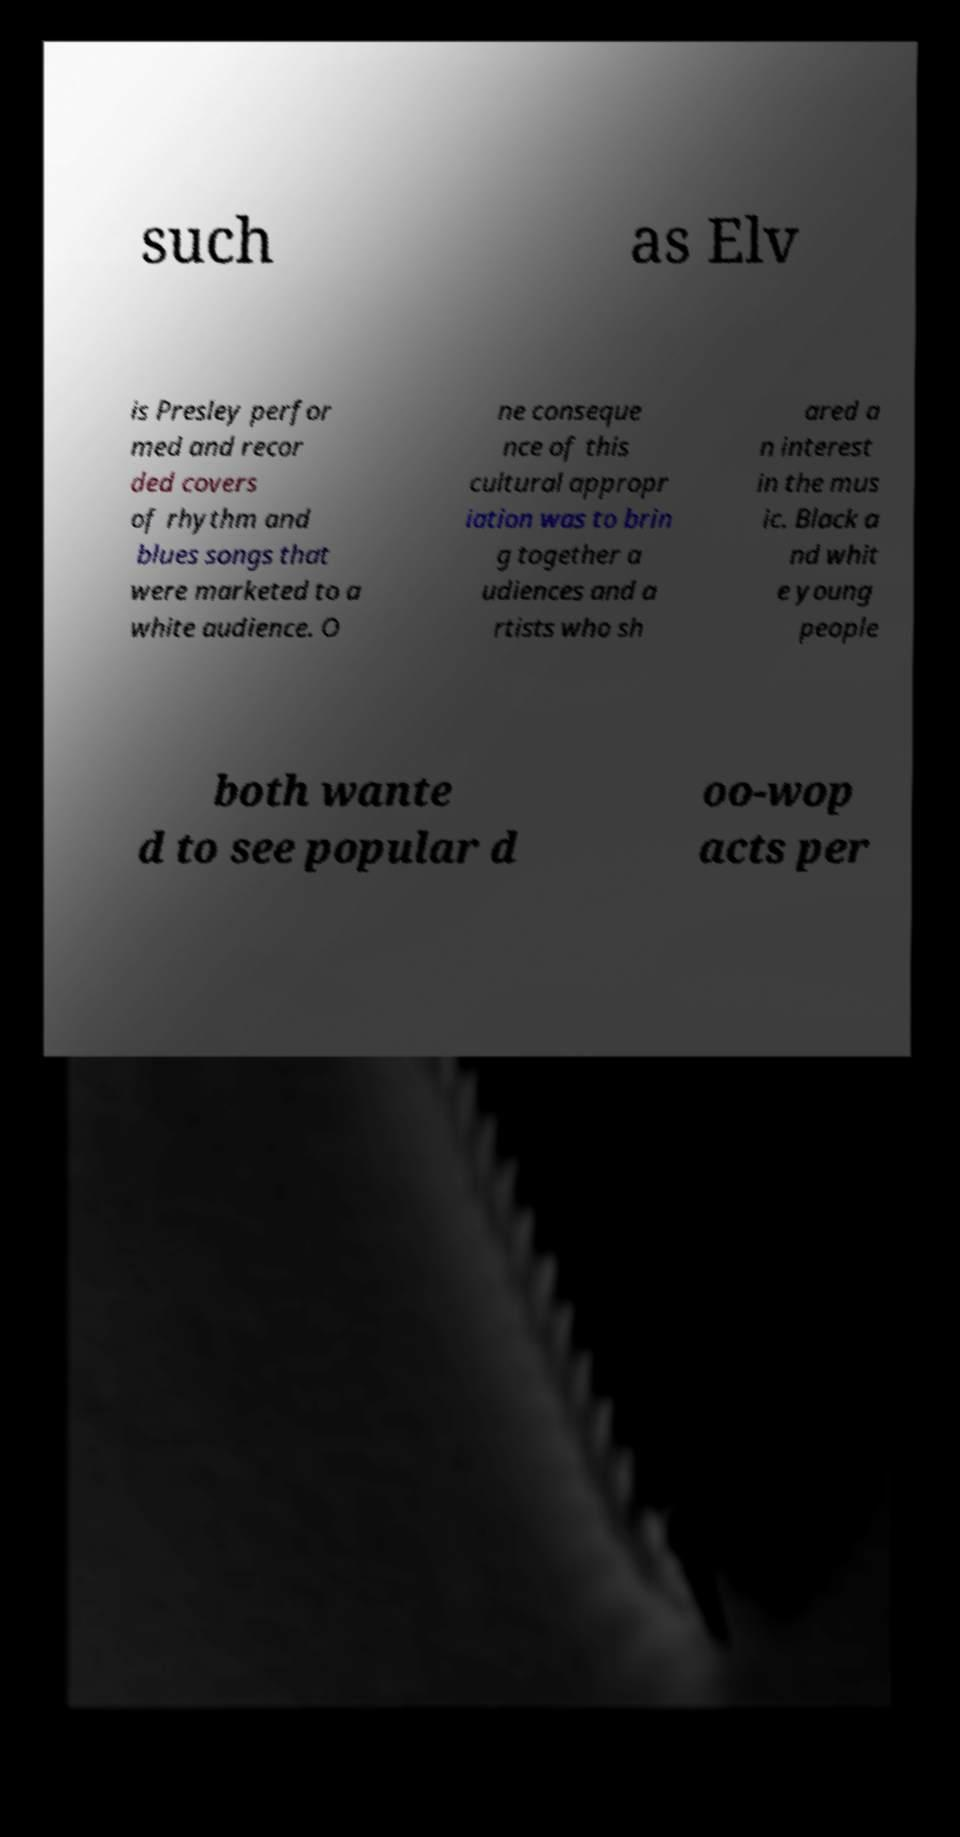There's text embedded in this image that I need extracted. Can you transcribe it verbatim? such as Elv is Presley perfor med and recor ded covers of rhythm and blues songs that were marketed to a white audience. O ne conseque nce of this cultural appropr iation was to brin g together a udiences and a rtists who sh ared a n interest in the mus ic. Black a nd whit e young people both wante d to see popular d oo-wop acts per 